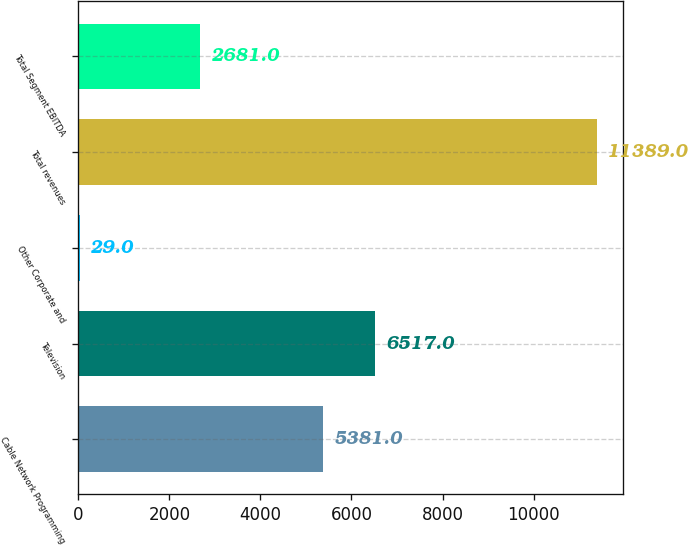<chart> <loc_0><loc_0><loc_500><loc_500><bar_chart><fcel>Cable Network Programming<fcel>Television<fcel>Other Corporate and<fcel>Total revenues<fcel>Total Segment EBITDA<nl><fcel>5381<fcel>6517<fcel>29<fcel>11389<fcel>2681<nl></chart> 